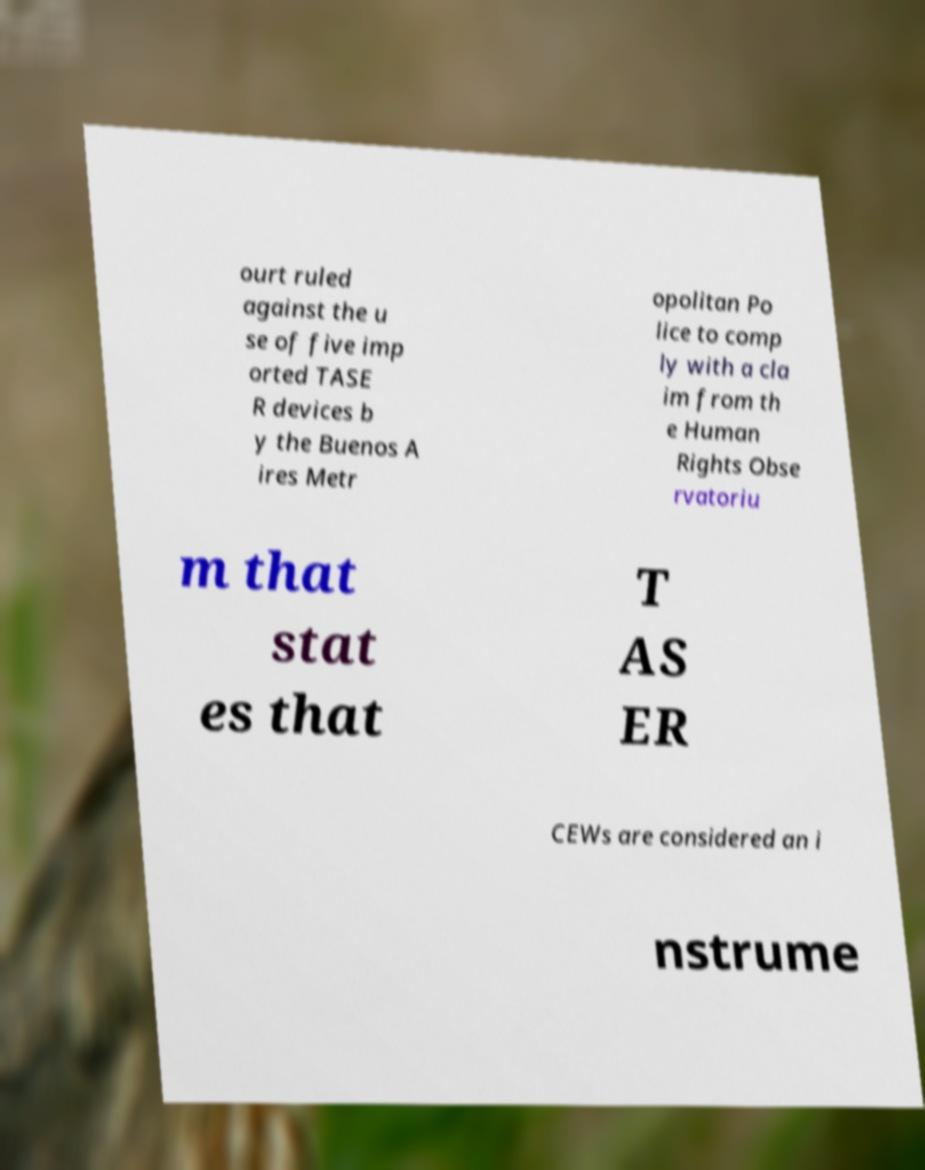Could you assist in decoding the text presented in this image and type it out clearly? ourt ruled against the u se of five imp orted TASE R devices b y the Buenos A ires Metr opolitan Po lice to comp ly with a cla im from th e Human Rights Obse rvatoriu m that stat es that T AS ER CEWs are considered an i nstrume 